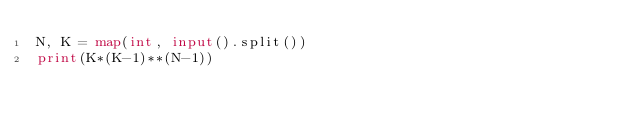Convert code to text. <code><loc_0><loc_0><loc_500><loc_500><_Python_>N, K = map(int, input().split())
print(K*(K-1)**(N-1))</code> 